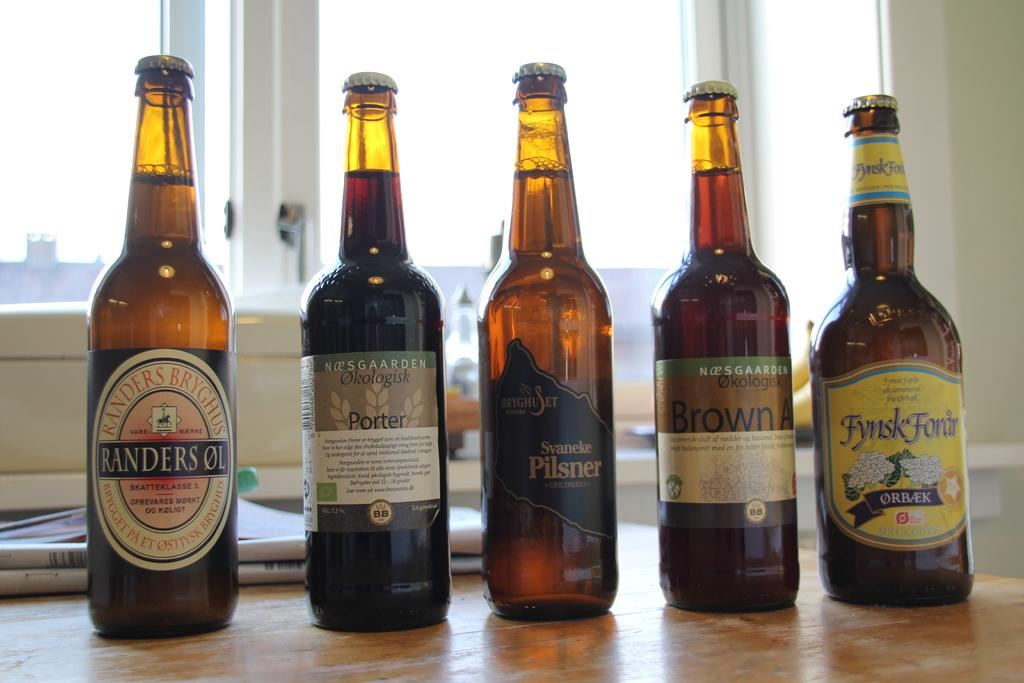<image>
Give a short and clear explanation of the subsequent image. Five beer bottles placed side by side including a one that says Svaneke Pilsner. 